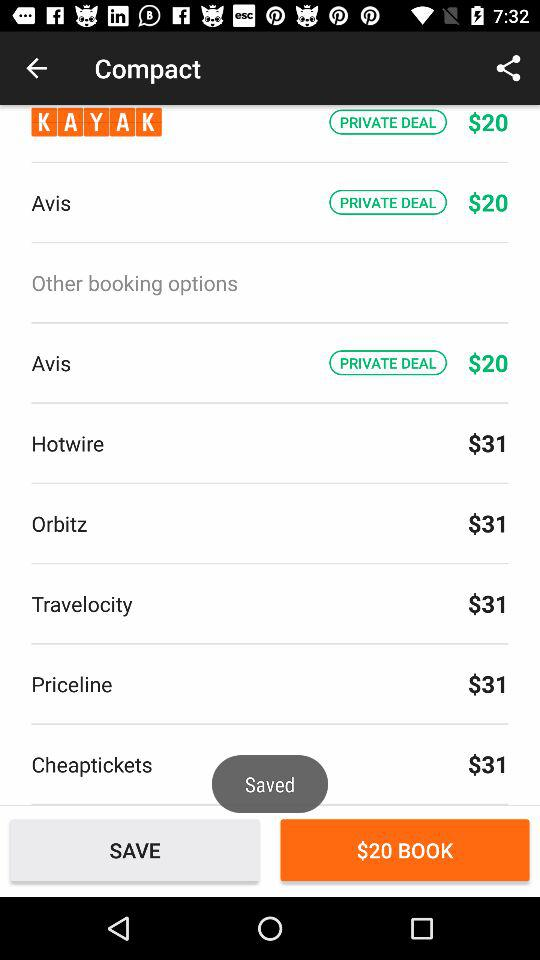How much cheaper is the cheapest booking option than the most expensive booking option?
Answer the question using a single word or phrase. $11 